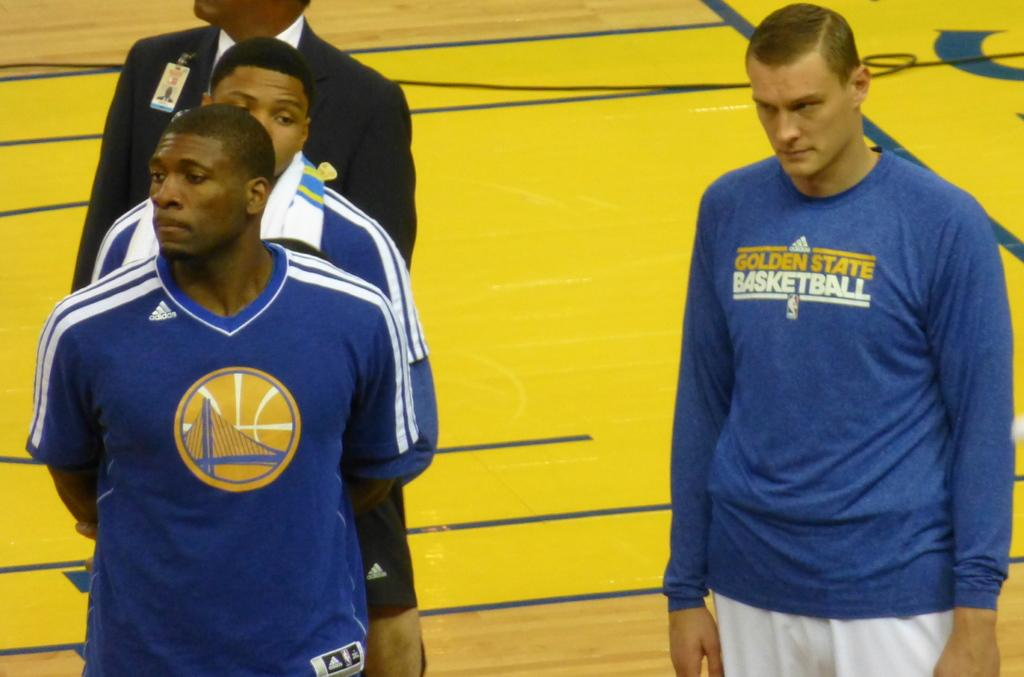<image>
Write a terse but informative summary of the picture. The three men were associated with Golden State Basketball. 